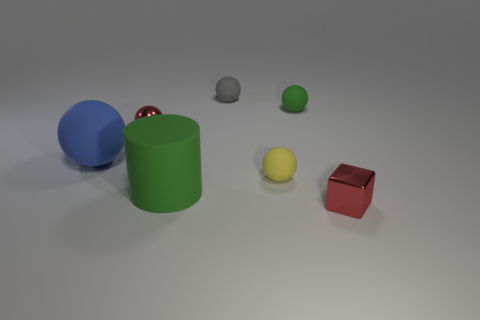The tiny matte object that is to the right of the gray ball and on the left side of the green matte sphere has what shape?
Your response must be concise. Sphere. What number of big rubber objects are left of the metal thing behind the shiny thing that is in front of the big blue object?
Your response must be concise. 1. The yellow thing that is the same shape as the large blue rubber object is what size?
Ensure brevity in your answer.  Small. Is there any other thing that is the same size as the yellow matte sphere?
Provide a succinct answer. Yes. Do the green thing that is in front of the large blue ball and the small green thing have the same material?
Give a very brief answer. Yes. There is a large matte object that is the same shape as the tiny gray object; what is its color?
Offer a very short reply. Blue. What number of other things are the same color as the tiny shiny sphere?
Offer a terse response. 1. Do the metal object that is to the left of the large green object and the red thing in front of the cylinder have the same shape?
Offer a very short reply. No. What number of cubes are tiny red objects or big blue rubber objects?
Offer a terse response. 1. Are there fewer big blue rubber balls that are behind the large ball than red objects?
Your answer should be compact. Yes. 